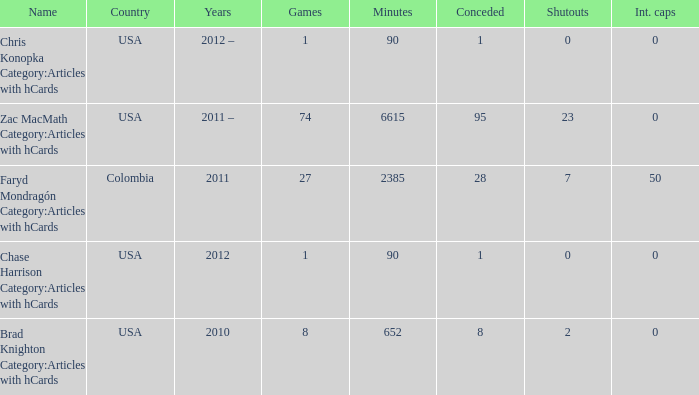When  chris konopka category:articles with hcards is the name what is the year? 2012 –. 